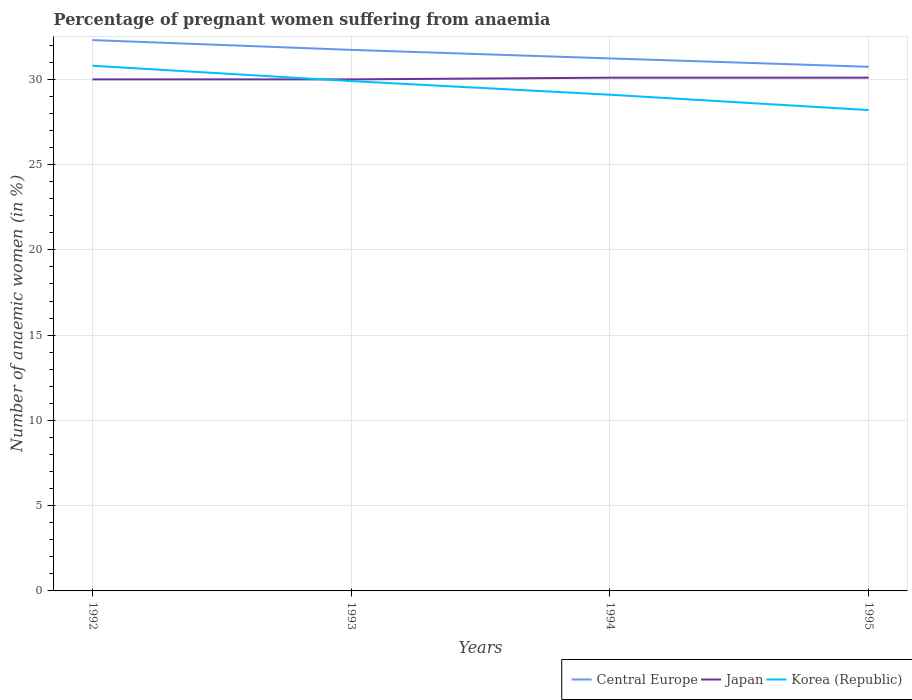How many different coloured lines are there?
Your answer should be very brief. 3. Does the line corresponding to Central Europe intersect with the line corresponding to Japan?
Keep it short and to the point. No. Across all years, what is the maximum number of anaemic women in Central Europe?
Offer a very short reply. 30.74. In which year was the number of anaemic women in Korea (Republic) maximum?
Make the answer very short. 1995. What is the total number of anaemic women in Japan in the graph?
Offer a terse response. -0.1. What is the difference between the highest and the second highest number of anaemic women in Japan?
Ensure brevity in your answer.  0.1. What is the difference between two consecutive major ticks on the Y-axis?
Offer a very short reply. 5. Does the graph contain any zero values?
Your answer should be compact. No. Does the graph contain grids?
Provide a short and direct response. Yes. How are the legend labels stacked?
Ensure brevity in your answer.  Horizontal. What is the title of the graph?
Your response must be concise. Percentage of pregnant women suffering from anaemia. What is the label or title of the X-axis?
Ensure brevity in your answer.  Years. What is the label or title of the Y-axis?
Your response must be concise. Number of anaemic women (in %). What is the Number of anaemic women (in %) in Central Europe in 1992?
Provide a succinct answer. 32.3. What is the Number of anaemic women (in %) in Japan in 1992?
Ensure brevity in your answer.  30. What is the Number of anaemic women (in %) in Korea (Republic) in 1992?
Make the answer very short. 30.8. What is the Number of anaemic women (in %) in Central Europe in 1993?
Make the answer very short. 31.73. What is the Number of anaemic women (in %) of Japan in 1993?
Provide a short and direct response. 30. What is the Number of anaemic women (in %) in Korea (Republic) in 1993?
Make the answer very short. 29.9. What is the Number of anaemic women (in %) in Central Europe in 1994?
Provide a short and direct response. 31.23. What is the Number of anaemic women (in %) in Japan in 1994?
Offer a terse response. 30.1. What is the Number of anaemic women (in %) in Korea (Republic) in 1994?
Your answer should be compact. 29.1. What is the Number of anaemic women (in %) in Central Europe in 1995?
Keep it short and to the point. 30.74. What is the Number of anaemic women (in %) in Japan in 1995?
Provide a short and direct response. 30.1. What is the Number of anaemic women (in %) in Korea (Republic) in 1995?
Your answer should be compact. 28.2. Across all years, what is the maximum Number of anaemic women (in %) of Central Europe?
Provide a short and direct response. 32.3. Across all years, what is the maximum Number of anaemic women (in %) of Japan?
Offer a very short reply. 30.1. Across all years, what is the maximum Number of anaemic women (in %) of Korea (Republic)?
Provide a short and direct response. 30.8. Across all years, what is the minimum Number of anaemic women (in %) in Central Europe?
Provide a short and direct response. 30.74. Across all years, what is the minimum Number of anaemic women (in %) of Korea (Republic)?
Your response must be concise. 28.2. What is the total Number of anaemic women (in %) in Central Europe in the graph?
Your answer should be compact. 126. What is the total Number of anaemic women (in %) in Japan in the graph?
Ensure brevity in your answer.  120.2. What is the total Number of anaemic women (in %) in Korea (Republic) in the graph?
Provide a succinct answer. 118. What is the difference between the Number of anaemic women (in %) of Central Europe in 1992 and that in 1993?
Provide a short and direct response. 0.57. What is the difference between the Number of anaemic women (in %) of Korea (Republic) in 1992 and that in 1993?
Provide a succinct answer. 0.9. What is the difference between the Number of anaemic women (in %) of Central Europe in 1992 and that in 1994?
Your response must be concise. 1.08. What is the difference between the Number of anaemic women (in %) of Central Europe in 1992 and that in 1995?
Give a very brief answer. 1.57. What is the difference between the Number of anaemic women (in %) of Japan in 1992 and that in 1995?
Your response must be concise. -0.1. What is the difference between the Number of anaemic women (in %) of Korea (Republic) in 1992 and that in 1995?
Give a very brief answer. 2.6. What is the difference between the Number of anaemic women (in %) of Central Europe in 1993 and that in 1994?
Provide a succinct answer. 0.5. What is the difference between the Number of anaemic women (in %) in Korea (Republic) in 1993 and that in 1994?
Keep it short and to the point. 0.8. What is the difference between the Number of anaemic women (in %) of Central Europe in 1993 and that in 1995?
Offer a very short reply. 0.99. What is the difference between the Number of anaemic women (in %) of Japan in 1993 and that in 1995?
Offer a terse response. -0.1. What is the difference between the Number of anaemic women (in %) of Korea (Republic) in 1993 and that in 1995?
Offer a very short reply. 1.7. What is the difference between the Number of anaemic women (in %) in Central Europe in 1994 and that in 1995?
Make the answer very short. 0.49. What is the difference between the Number of anaemic women (in %) in Japan in 1994 and that in 1995?
Your answer should be compact. 0. What is the difference between the Number of anaemic women (in %) of Central Europe in 1992 and the Number of anaemic women (in %) of Japan in 1993?
Ensure brevity in your answer.  2.3. What is the difference between the Number of anaemic women (in %) in Central Europe in 1992 and the Number of anaemic women (in %) in Korea (Republic) in 1993?
Offer a terse response. 2.4. What is the difference between the Number of anaemic women (in %) in Japan in 1992 and the Number of anaemic women (in %) in Korea (Republic) in 1993?
Give a very brief answer. 0.1. What is the difference between the Number of anaemic women (in %) in Central Europe in 1992 and the Number of anaemic women (in %) in Japan in 1994?
Provide a succinct answer. 2.2. What is the difference between the Number of anaemic women (in %) of Central Europe in 1992 and the Number of anaemic women (in %) of Korea (Republic) in 1994?
Make the answer very short. 3.2. What is the difference between the Number of anaemic women (in %) of Central Europe in 1992 and the Number of anaemic women (in %) of Japan in 1995?
Your response must be concise. 2.2. What is the difference between the Number of anaemic women (in %) of Central Europe in 1992 and the Number of anaemic women (in %) of Korea (Republic) in 1995?
Your answer should be very brief. 4.1. What is the difference between the Number of anaemic women (in %) of Central Europe in 1993 and the Number of anaemic women (in %) of Japan in 1994?
Your answer should be compact. 1.63. What is the difference between the Number of anaemic women (in %) in Central Europe in 1993 and the Number of anaemic women (in %) in Korea (Republic) in 1994?
Offer a very short reply. 2.63. What is the difference between the Number of anaemic women (in %) of Japan in 1993 and the Number of anaemic women (in %) of Korea (Republic) in 1994?
Your answer should be compact. 0.9. What is the difference between the Number of anaemic women (in %) of Central Europe in 1993 and the Number of anaemic women (in %) of Japan in 1995?
Provide a succinct answer. 1.63. What is the difference between the Number of anaemic women (in %) of Central Europe in 1993 and the Number of anaemic women (in %) of Korea (Republic) in 1995?
Your answer should be compact. 3.53. What is the difference between the Number of anaemic women (in %) in Central Europe in 1994 and the Number of anaemic women (in %) in Japan in 1995?
Keep it short and to the point. 1.13. What is the difference between the Number of anaemic women (in %) of Central Europe in 1994 and the Number of anaemic women (in %) of Korea (Republic) in 1995?
Your response must be concise. 3.03. What is the average Number of anaemic women (in %) in Central Europe per year?
Provide a succinct answer. 31.5. What is the average Number of anaemic women (in %) in Japan per year?
Keep it short and to the point. 30.05. What is the average Number of anaemic women (in %) in Korea (Republic) per year?
Your answer should be very brief. 29.5. In the year 1992, what is the difference between the Number of anaemic women (in %) of Central Europe and Number of anaemic women (in %) of Japan?
Your response must be concise. 2.3. In the year 1992, what is the difference between the Number of anaemic women (in %) of Central Europe and Number of anaemic women (in %) of Korea (Republic)?
Offer a terse response. 1.5. In the year 1992, what is the difference between the Number of anaemic women (in %) of Japan and Number of anaemic women (in %) of Korea (Republic)?
Make the answer very short. -0.8. In the year 1993, what is the difference between the Number of anaemic women (in %) in Central Europe and Number of anaemic women (in %) in Japan?
Offer a terse response. 1.73. In the year 1993, what is the difference between the Number of anaemic women (in %) of Central Europe and Number of anaemic women (in %) of Korea (Republic)?
Keep it short and to the point. 1.83. In the year 1994, what is the difference between the Number of anaemic women (in %) of Central Europe and Number of anaemic women (in %) of Japan?
Keep it short and to the point. 1.13. In the year 1994, what is the difference between the Number of anaemic women (in %) in Central Europe and Number of anaemic women (in %) in Korea (Republic)?
Give a very brief answer. 2.13. In the year 1995, what is the difference between the Number of anaemic women (in %) in Central Europe and Number of anaemic women (in %) in Japan?
Make the answer very short. 0.64. In the year 1995, what is the difference between the Number of anaemic women (in %) of Central Europe and Number of anaemic women (in %) of Korea (Republic)?
Ensure brevity in your answer.  2.54. In the year 1995, what is the difference between the Number of anaemic women (in %) in Japan and Number of anaemic women (in %) in Korea (Republic)?
Ensure brevity in your answer.  1.9. What is the ratio of the Number of anaemic women (in %) of Central Europe in 1992 to that in 1993?
Offer a very short reply. 1.02. What is the ratio of the Number of anaemic women (in %) in Korea (Republic) in 1992 to that in 1993?
Offer a very short reply. 1.03. What is the ratio of the Number of anaemic women (in %) in Central Europe in 1992 to that in 1994?
Your answer should be very brief. 1.03. What is the ratio of the Number of anaemic women (in %) in Japan in 1992 to that in 1994?
Your answer should be very brief. 1. What is the ratio of the Number of anaemic women (in %) in Korea (Republic) in 1992 to that in 1994?
Your answer should be very brief. 1.06. What is the ratio of the Number of anaemic women (in %) in Central Europe in 1992 to that in 1995?
Keep it short and to the point. 1.05. What is the ratio of the Number of anaemic women (in %) in Korea (Republic) in 1992 to that in 1995?
Offer a very short reply. 1.09. What is the ratio of the Number of anaemic women (in %) of Central Europe in 1993 to that in 1994?
Your answer should be very brief. 1.02. What is the ratio of the Number of anaemic women (in %) in Korea (Republic) in 1993 to that in 1994?
Provide a succinct answer. 1.03. What is the ratio of the Number of anaemic women (in %) of Central Europe in 1993 to that in 1995?
Keep it short and to the point. 1.03. What is the ratio of the Number of anaemic women (in %) in Korea (Republic) in 1993 to that in 1995?
Give a very brief answer. 1.06. What is the ratio of the Number of anaemic women (in %) in Central Europe in 1994 to that in 1995?
Your answer should be very brief. 1.02. What is the ratio of the Number of anaemic women (in %) of Japan in 1994 to that in 1995?
Provide a short and direct response. 1. What is the ratio of the Number of anaemic women (in %) of Korea (Republic) in 1994 to that in 1995?
Your response must be concise. 1.03. What is the difference between the highest and the second highest Number of anaemic women (in %) of Central Europe?
Your answer should be compact. 0.57. What is the difference between the highest and the lowest Number of anaemic women (in %) in Central Europe?
Make the answer very short. 1.57. 